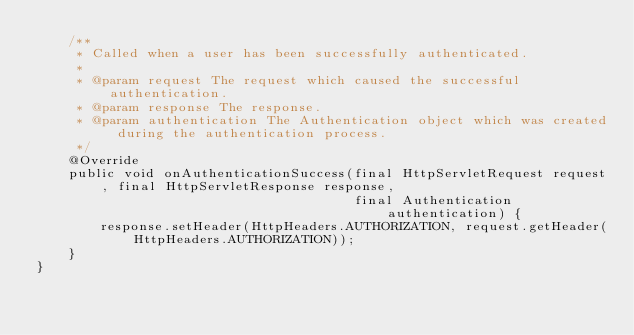Convert code to text. <code><loc_0><loc_0><loc_500><loc_500><_Java_>    /**
     * Called when a user has been successfully authenticated.
     *
     * @param request The request which caused the successful authentication.
     * @param response The response.
     * @param authentication The Authentication object which was created during the authentication process.
     */
    @Override
    public void onAuthenticationSuccess(final HttpServletRequest request, final HttpServletResponse response,
                                        final Authentication authentication) {
        response.setHeader(HttpHeaders.AUTHORIZATION, request.getHeader(HttpHeaders.AUTHORIZATION));
    }
}
</code> 